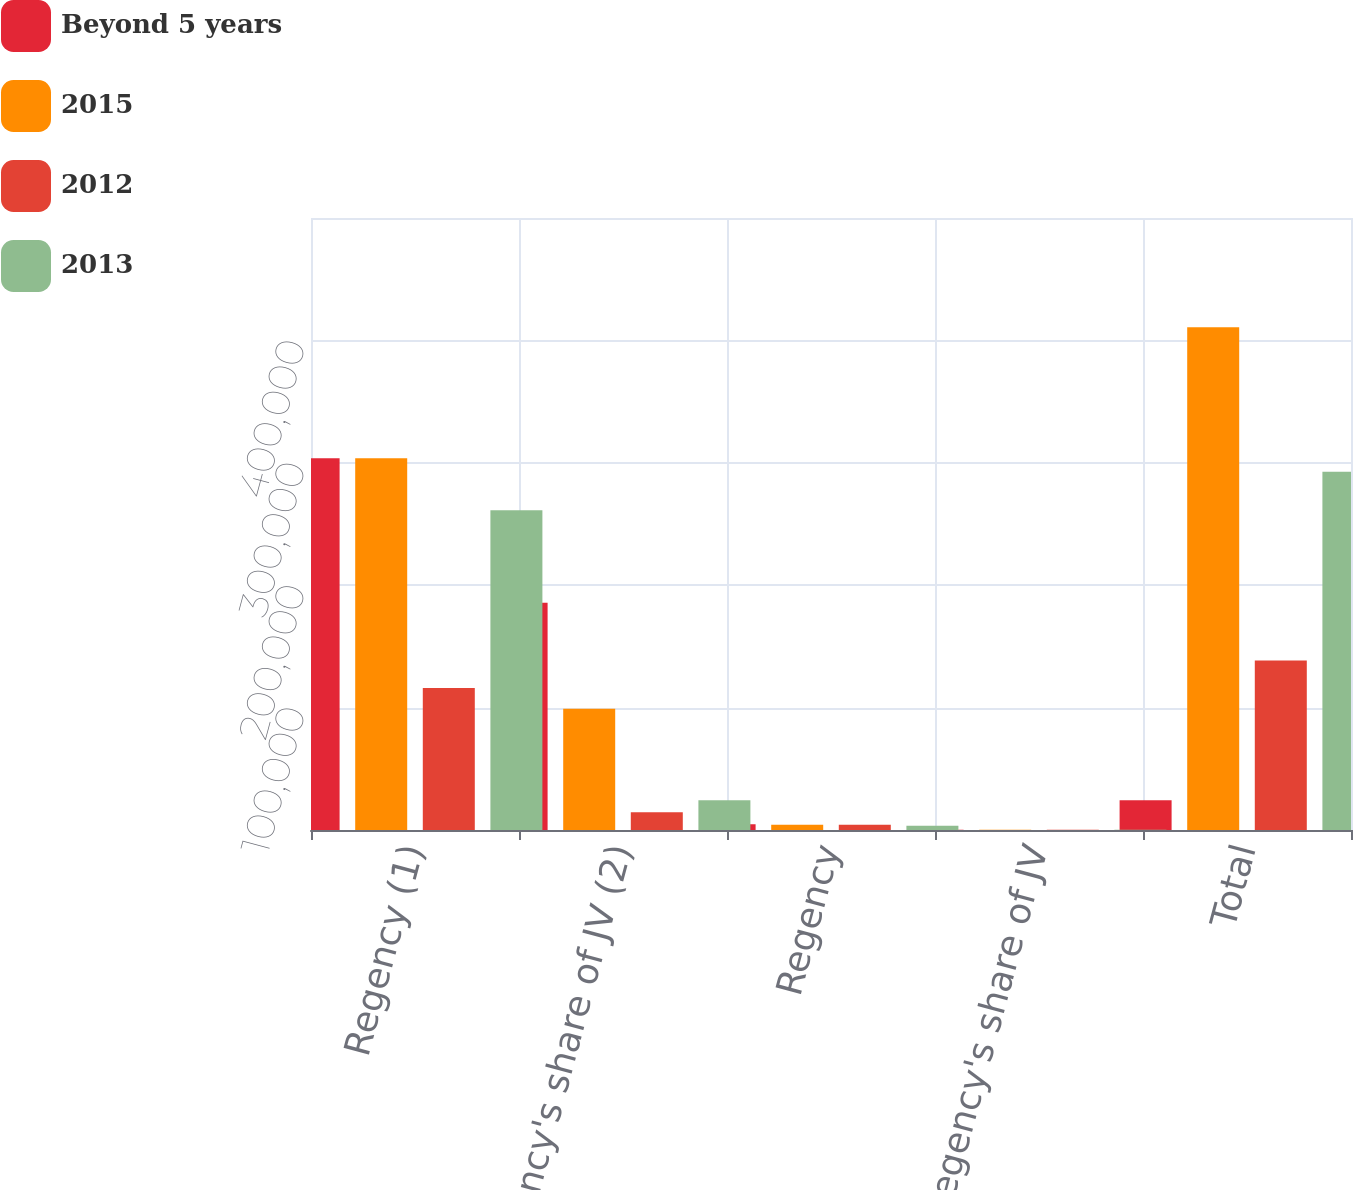Convert chart. <chart><loc_0><loc_0><loc_500><loc_500><stacked_bar_chart><ecel><fcel>Regency (1)<fcel>Regency's share of JV (2)<fcel>Regency<fcel>Regency's share of JV<fcel>Total<nl><fcel>Beyond 5 years<fcel>303818<fcel>185651<fcel>4695<fcel>264<fcel>24346<nl><fcel>2015<fcel>303736<fcel>98977<fcel>4390<fcel>264<fcel>410724<nl><fcel>2012<fcel>116093<fcel>14567<fcel>4267<fcel>265<fcel>138546<nl><fcel>2013<fcel>261241<fcel>24346<fcel>3562<fcel>265<fcel>292775<nl></chart> 